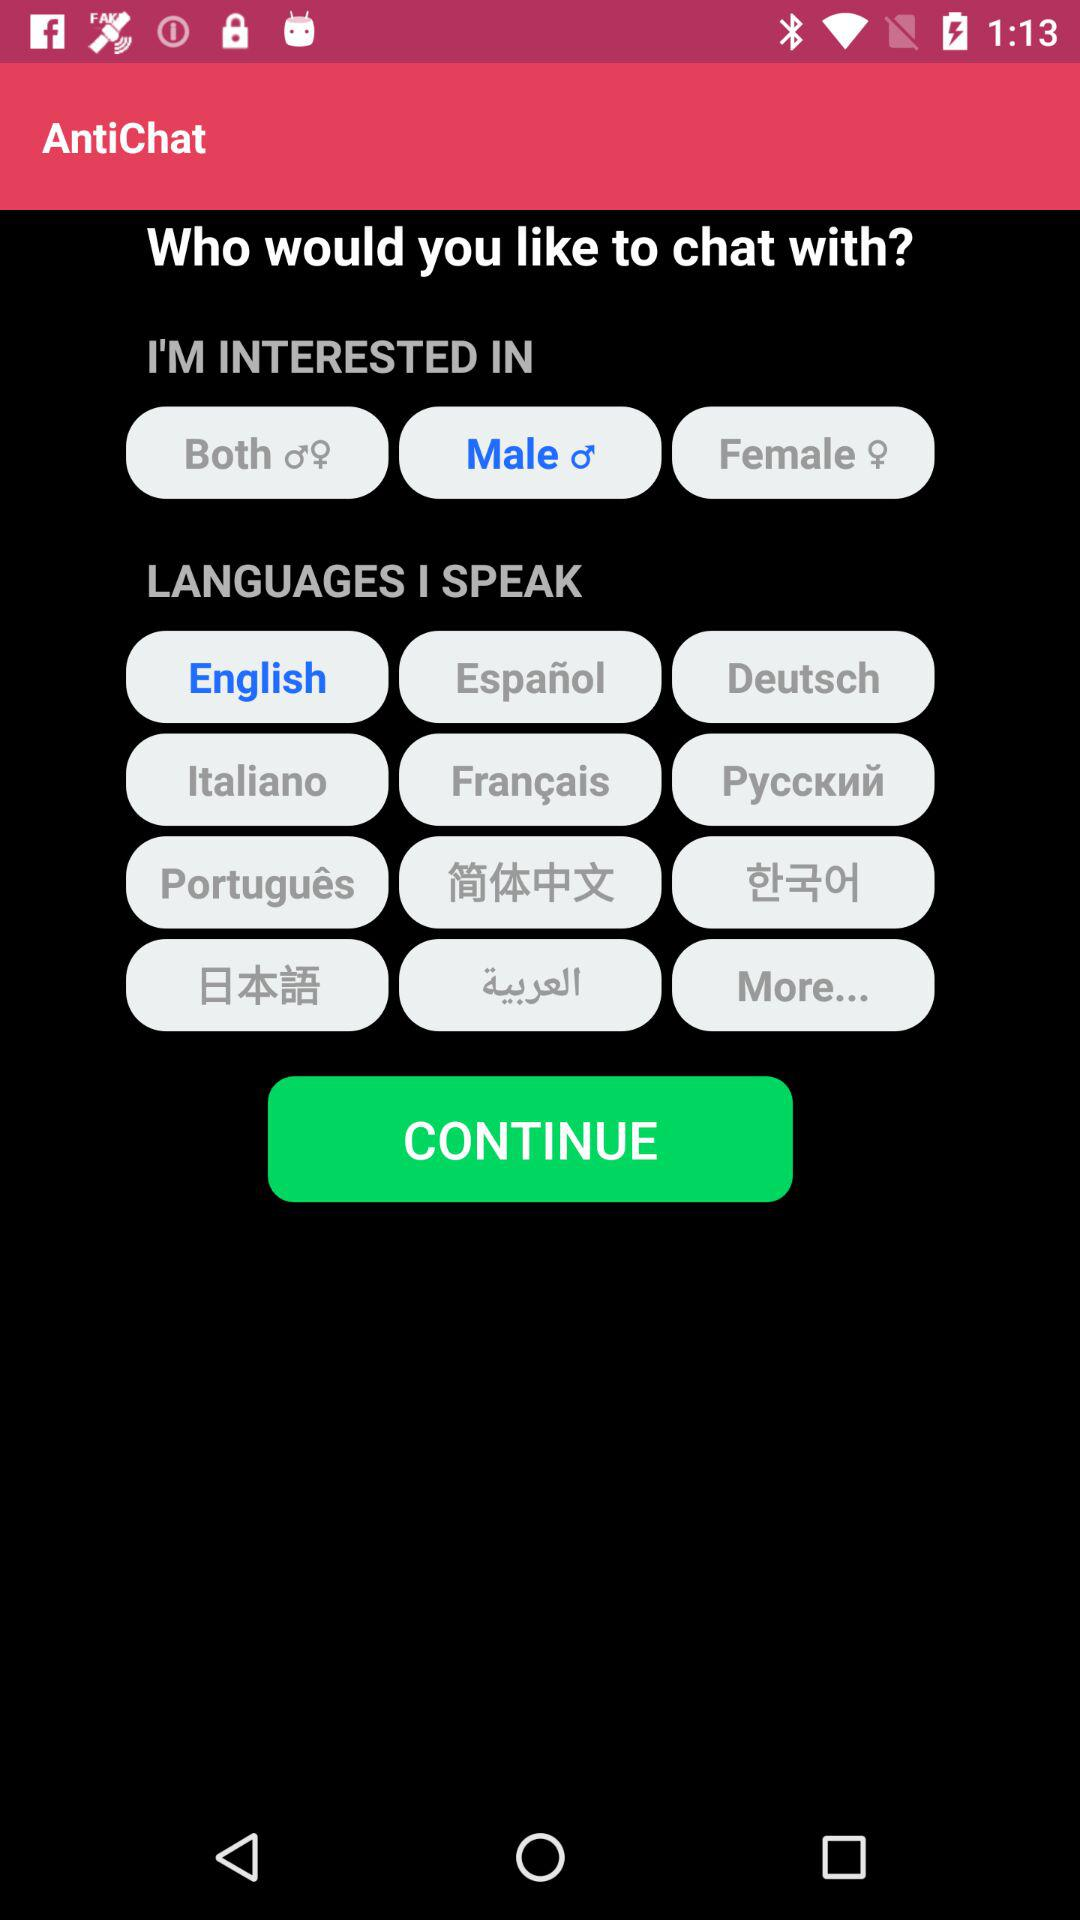Which option is selected as my chat interest? The selected option is "Male". 